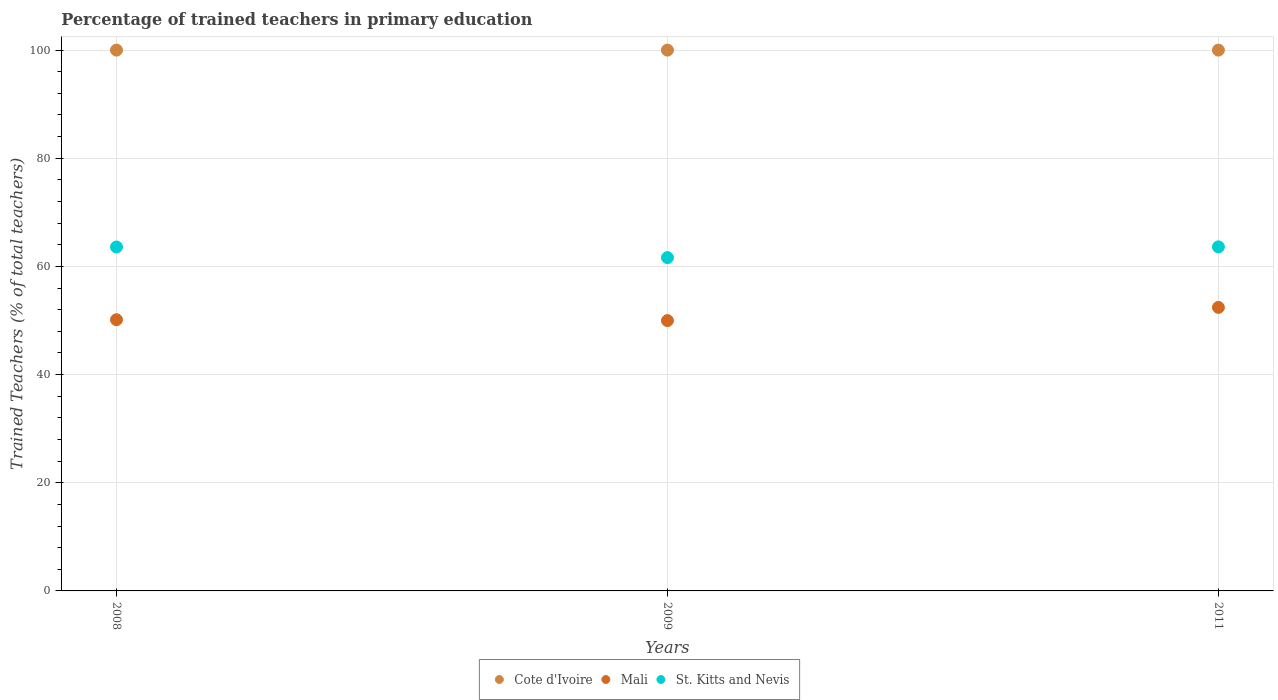How many different coloured dotlines are there?
Provide a short and direct response. 3. What is the percentage of trained teachers in St. Kitts and Nevis in 2009?
Your response must be concise. 61.63. Across all years, what is the minimum percentage of trained teachers in Mali?
Your answer should be very brief. 49.98. In which year was the percentage of trained teachers in Mali maximum?
Your answer should be compact. 2011. In which year was the percentage of trained teachers in Mali minimum?
Your response must be concise. 2009. What is the total percentage of trained teachers in St. Kitts and Nevis in the graph?
Your answer should be very brief. 188.83. What is the difference between the percentage of trained teachers in Mali in 2008 and that in 2009?
Ensure brevity in your answer.  0.16. What is the difference between the percentage of trained teachers in Mali in 2011 and the percentage of trained teachers in St. Kitts and Nevis in 2008?
Provide a short and direct response. -11.17. What is the average percentage of trained teachers in Mali per year?
Give a very brief answer. 50.85. In the year 2009, what is the difference between the percentage of trained teachers in Mali and percentage of trained teachers in Cote d'Ivoire?
Your response must be concise. -50.02. In how many years, is the percentage of trained teachers in Cote d'Ivoire greater than 68 %?
Your answer should be very brief. 3. What is the ratio of the percentage of trained teachers in St. Kitts and Nevis in 2008 to that in 2009?
Ensure brevity in your answer.  1.03. Is the difference between the percentage of trained teachers in Mali in 2009 and 2011 greater than the difference between the percentage of trained teachers in Cote d'Ivoire in 2009 and 2011?
Give a very brief answer. No. What is the difference between the highest and the second highest percentage of trained teachers in Mali?
Your response must be concise. 2.28. What is the difference between the highest and the lowest percentage of trained teachers in Cote d'Ivoire?
Offer a terse response. 0. In how many years, is the percentage of trained teachers in Cote d'Ivoire greater than the average percentage of trained teachers in Cote d'Ivoire taken over all years?
Your answer should be compact. 0. Is the sum of the percentage of trained teachers in St. Kitts and Nevis in 2009 and 2011 greater than the maximum percentage of trained teachers in Mali across all years?
Provide a short and direct response. Yes. Is it the case that in every year, the sum of the percentage of trained teachers in Cote d'Ivoire and percentage of trained teachers in Mali  is greater than the percentage of trained teachers in St. Kitts and Nevis?
Offer a terse response. Yes. Does the percentage of trained teachers in Mali monotonically increase over the years?
Make the answer very short. No. Is the percentage of trained teachers in St. Kitts and Nevis strictly less than the percentage of trained teachers in Mali over the years?
Offer a terse response. No. How many dotlines are there?
Give a very brief answer. 3. How many years are there in the graph?
Offer a terse response. 3. Are the values on the major ticks of Y-axis written in scientific E-notation?
Offer a terse response. No. Does the graph contain any zero values?
Keep it short and to the point. No. Where does the legend appear in the graph?
Your answer should be very brief. Bottom center. How are the legend labels stacked?
Your answer should be very brief. Horizontal. What is the title of the graph?
Keep it short and to the point. Percentage of trained teachers in primary education. What is the label or title of the X-axis?
Keep it short and to the point. Years. What is the label or title of the Y-axis?
Your answer should be very brief. Trained Teachers (% of total teachers). What is the Trained Teachers (% of total teachers) in Mali in 2008?
Provide a short and direct response. 50.14. What is the Trained Teachers (% of total teachers) of St. Kitts and Nevis in 2008?
Provide a succinct answer. 63.59. What is the Trained Teachers (% of total teachers) in Cote d'Ivoire in 2009?
Offer a terse response. 100. What is the Trained Teachers (% of total teachers) of Mali in 2009?
Offer a terse response. 49.98. What is the Trained Teachers (% of total teachers) of St. Kitts and Nevis in 2009?
Your response must be concise. 61.63. What is the Trained Teachers (% of total teachers) of Mali in 2011?
Make the answer very short. 52.42. What is the Trained Teachers (% of total teachers) in St. Kitts and Nevis in 2011?
Your answer should be compact. 63.62. Across all years, what is the maximum Trained Teachers (% of total teachers) of Cote d'Ivoire?
Provide a succinct answer. 100. Across all years, what is the maximum Trained Teachers (% of total teachers) of Mali?
Offer a terse response. 52.42. Across all years, what is the maximum Trained Teachers (% of total teachers) of St. Kitts and Nevis?
Your answer should be very brief. 63.62. Across all years, what is the minimum Trained Teachers (% of total teachers) in Mali?
Provide a succinct answer. 49.98. Across all years, what is the minimum Trained Teachers (% of total teachers) in St. Kitts and Nevis?
Your response must be concise. 61.63. What is the total Trained Teachers (% of total teachers) in Cote d'Ivoire in the graph?
Ensure brevity in your answer.  300. What is the total Trained Teachers (% of total teachers) in Mali in the graph?
Offer a very short reply. 152.55. What is the total Trained Teachers (% of total teachers) in St. Kitts and Nevis in the graph?
Offer a terse response. 188.83. What is the difference between the Trained Teachers (% of total teachers) in Mali in 2008 and that in 2009?
Ensure brevity in your answer.  0.16. What is the difference between the Trained Teachers (% of total teachers) of St. Kitts and Nevis in 2008 and that in 2009?
Make the answer very short. 1.97. What is the difference between the Trained Teachers (% of total teachers) of Mali in 2008 and that in 2011?
Offer a very short reply. -2.28. What is the difference between the Trained Teachers (% of total teachers) of St. Kitts and Nevis in 2008 and that in 2011?
Offer a terse response. -0.03. What is the difference between the Trained Teachers (% of total teachers) in Mali in 2009 and that in 2011?
Ensure brevity in your answer.  -2.44. What is the difference between the Trained Teachers (% of total teachers) of St. Kitts and Nevis in 2009 and that in 2011?
Provide a succinct answer. -1.99. What is the difference between the Trained Teachers (% of total teachers) in Cote d'Ivoire in 2008 and the Trained Teachers (% of total teachers) in Mali in 2009?
Offer a very short reply. 50.02. What is the difference between the Trained Teachers (% of total teachers) of Cote d'Ivoire in 2008 and the Trained Teachers (% of total teachers) of St. Kitts and Nevis in 2009?
Ensure brevity in your answer.  38.37. What is the difference between the Trained Teachers (% of total teachers) in Mali in 2008 and the Trained Teachers (% of total teachers) in St. Kitts and Nevis in 2009?
Provide a short and direct response. -11.48. What is the difference between the Trained Teachers (% of total teachers) in Cote d'Ivoire in 2008 and the Trained Teachers (% of total teachers) in Mali in 2011?
Offer a terse response. 47.58. What is the difference between the Trained Teachers (% of total teachers) in Cote d'Ivoire in 2008 and the Trained Teachers (% of total teachers) in St. Kitts and Nevis in 2011?
Make the answer very short. 36.38. What is the difference between the Trained Teachers (% of total teachers) in Mali in 2008 and the Trained Teachers (% of total teachers) in St. Kitts and Nevis in 2011?
Your answer should be very brief. -13.47. What is the difference between the Trained Teachers (% of total teachers) in Cote d'Ivoire in 2009 and the Trained Teachers (% of total teachers) in Mali in 2011?
Make the answer very short. 47.58. What is the difference between the Trained Teachers (% of total teachers) of Cote d'Ivoire in 2009 and the Trained Teachers (% of total teachers) of St. Kitts and Nevis in 2011?
Keep it short and to the point. 36.38. What is the difference between the Trained Teachers (% of total teachers) of Mali in 2009 and the Trained Teachers (% of total teachers) of St. Kitts and Nevis in 2011?
Ensure brevity in your answer.  -13.63. What is the average Trained Teachers (% of total teachers) of Cote d'Ivoire per year?
Provide a succinct answer. 100. What is the average Trained Teachers (% of total teachers) of Mali per year?
Give a very brief answer. 50.85. What is the average Trained Teachers (% of total teachers) of St. Kitts and Nevis per year?
Keep it short and to the point. 62.94. In the year 2008, what is the difference between the Trained Teachers (% of total teachers) in Cote d'Ivoire and Trained Teachers (% of total teachers) in Mali?
Your answer should be compact. 49.86. In the year 2008, what is the difference between the Trained Teachers (% of total teachers) in Cote d'Ivoire and Trained Teachers (% of total teachers) in St. Kitts and Nevis?
Your response must be concise. 36.41. In the year 2008, what is the difference between the Trained Teachers (% of total teachers) of Mali and Trained Teachers (% of total teachers) of St. Kitts and Nevis?
Your answer should be very brief. -13.45. In the year 2009, what is the difference between the Trained Teachers (% of total teachers) in Cote d'Ivoire and Trained Teachers (% of total teachers) in Mali?
Make the answer very short. 50.02. In the year 2009, what is the difference between the Trained Teachers (% of total teachers) in Cote d'Ivoire and Trained Teachers (% of total teachers) in St. Kitts and Nevis?
Provide a succinct answer. 38.37. In the year 2009, what is the difference between the Trained Teachers (% of total teachers) in Mali and Trained Teachers (% of total teachers) in St. Kitts and Nevis?
Offer a very short reply. -11.64. In the year 2011, what is the difference between the Trained Teachers (% of total teachers) in Cote d'Ivoire and Trained Teachers (% of total teachers) in Mali?
Give a very brief answer. 47.58. In the year 2011, what is the difference between the Trained Teachers (% of total teachers) in Cote d'Ivoire and Trained Teachers (% of total teachers) in St. Kitts and Nevis?
Your response must be concise. 36.38. In the year 2011, what is the difference between the Trained Teachers (% of total teachers) of Mali and Trained Teachers (% of total teachers) of St. Kitts and Nevis?
Your answer should be very brief. -11.19. What is the ratio of the Trained Teachers (% of total teachers) in St. Kitts and Nevis in 2008 to that in 2009?
Provide a short and direct response. 1.03. What is the ratio of the Trained Teachers (% of total teachers) of Mali in 2008 to that in 2011?
Ensure brevity in your answer.  0.96. What is the ratio of the Trained Teachers (% of total teachers) of Cote d'Ivoire in 2009 to that in 2011?
Provide a short and direct response. 1. What is the ratio of the Trained Teachers (% of total teachers) of Mali in 2009 to that in 2011?
Offer a terse response. 0.95. What is the ratio of the Trained Teachers (% of total teachers) of St. Kitts and Nevis in 2009 to that in 2011?
Ensure brevity in your answer.  0.97. What is the difference between the highest and the second highest Trained Teachers (% of total teachers) in Cote d'Ivoire?
Make the answer very short. 0. What is the difference between the highest and the second highest Trained Teachers (% of total teachers) in Mali?
Provide a succinct answer. 2.28. What is the difference between the highest and the second highest Trained Teachers (% of total teachers) in St. Kitts and Nevis?
Offer a terse response. 0.03. What is the difference between the highest and the lowest Trained Teachers (% of total teachers) in Cote d'Ivoire?
Ensure brevity in your answer.  0. What is the difference between the highest and the lowest Trained Teachers (% of total teachers) of Mali?
Make the answer very short. 2.44. What is the difference between the highest and the lowest Trained Teachers (% of total teachers) in St. Kitts and Nevis?
Keep it short and to the point. 1.99. 